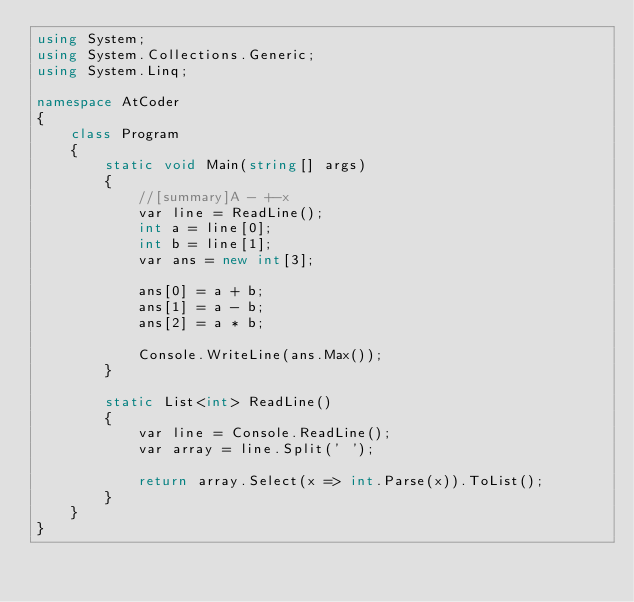Convert code to text. <code><loc_0><loc_0><loc_500><loc_500><_C#_>using System;
using System.Collections.Generic;
using System.Linq;

namespace AtCoder
{
    class Program
    {
        static void Main(string[] args)
        {
            //[summary]A - +-x
            var line = ReadLine();
            int a = line[0];
            int b = line[1];
            var ans = new int[3];

            ans[0] = a + b;
            ans[1] = a - b;
            ans[2] = a * b;

            Console.WriteLine(ans.Max());
        }

        static List<int> ReadLine()
        {
            var line = Console.ReadLine();
            var array = line.Split(' ');

            return array.Select(x => int.Parse(x)).ToList();
        }
    }
}</code> 